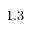<formula> <loc_0><loc_0><loc_500><loc_500>1 . 3</formula> 